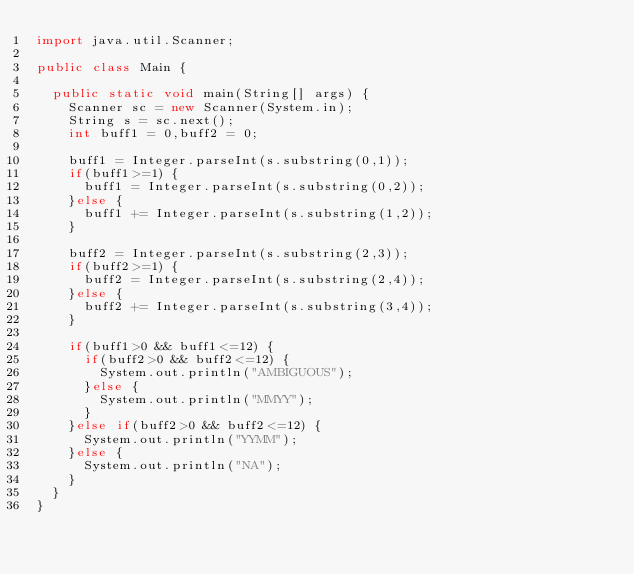<code> <loc_0><loc_0><loc_500><loc_500><_Java_>import java.util.Scanner;

public class Main {

	public static void main(String[] args) {
		Scanner sc = new Scanner(System.in);
		String s = sc.next();
		int buff1 = 0,buff2 = 0;

		buff1 = Integer.parseInt(s.substring(0,1));
		if(buff1>=1) {
			buff1 = Integer.parseInt(s.substring(0,2));
		}else {
			buff1 += Integer.parseInt(s.substring(1,2));
		}

		buff2 = Integer.parseInt(s.substring(2,3));
		if(buff2>=1) {
			buff2 = Integer.parseInt(s.substring(2,4));
		}else {
			buff2 += Integer.parseInt(s.substring(3,4));
		}

		if(buff1>0 && buff1<=12) {
			if(buff2>0 && buff2<=12) {
				System.out.println("AMBIGUOUS");
			}else {
				System.out.println("MMYY");
			}
		}else if(buff2>0 && buff2<=12) {
			System.out.println("YYMM");
		}else {
			System.out.println("NA");
		}
	}
}


</code> 